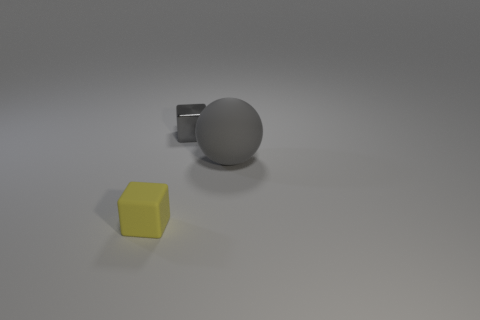Add 1 small yellow matte things. How many objects exist? 4 Subtract all spheres. How many objects are left? 2 Subtract 0 purple balls. How many objects are left? 3 Subtract all yellow cubes. Subtract all big gray spheres. How many objects are left? 1 Add 1 gray balls. How many gray balls are left? 2 Add 2 big gray objects. How many big gray objects exist? 3 